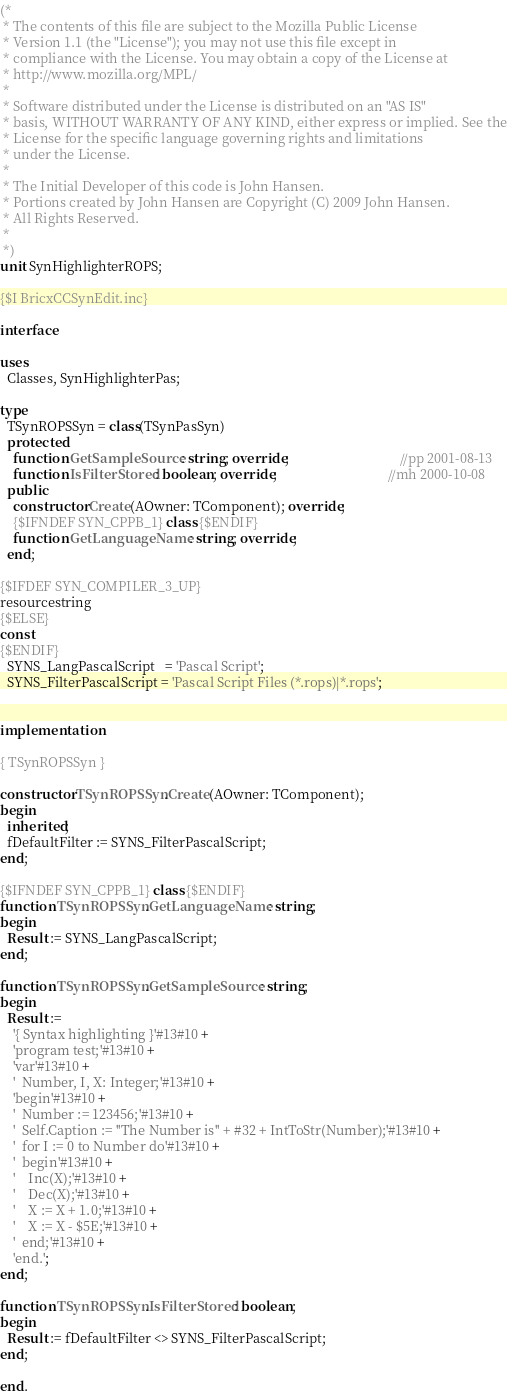<code> <loc_0><loc_0><loc_500><loc_500><_Pascal_>(*
 * The contents of this file are subject to the Mozilla Public License
 * Version 1.1 (the "License"); you may not use this file except in
 * compliance with the License. You may obtain a copy of the License at
 * http://www.mozilla.org/MPL/
 *
 * Software distributed under the License is distributed on an "AS IS"
 * basis, WITHOUT WARRANTY OF ANY KIND, either express or implied. See the
 * License for the specific language governing rights and limitations
 * under the License.
 *
 * The Initial Developer of this code is John Hansen.
 * Portions created by John Hansen are Copyright (C) 2009 John Hansen.
 * All Rights Reserved.
 *
 *)
unit SynHighlighterROPS;

{$I BricxCCSynEdit.inc}

interface

uses
  Classes, SynHighlighterPas;

type
  TSynROPSSyn = class(TSynPasSyn)
  protected
    function GetSampleSource: string; override;                                 //pp 2001-08-13
    function IsFilterStored: boolean; override;                                 //mh 2000-10-08
  public
    constructor Create(AOwner: TComponent); override;
    {$IFNDEF SYN_CPPB_1} class {$ENDIF}
    function GetLanguageName: string; override;
  end;

{$IFDEF SYN_COMPILER_3_UP}
resourcestring
{$ELSE}
const
{$ENDIF}
  SYNS_LangPascalScript   = 'Pascal Script';
  SYNS_FilterPascalScript = 'Pascal Script Files (*.rops)|*.rops';


implementation

{ TSynROPSSyn }

constructor TSynROPSSyn.Create(AOwner: TComponent);
begin
  inherited;
  fDefaultFilter := SYNS_FilterPascalScript;
end;

{$IFNDEF SYN_CPPB_1} class {$ENDIF}
function TSynROPSSyn.GetLanguageName: string;
begin
  Result := SYNS_LangPascalScript;
end;

function TSynROPSSyn.GetSampleSource: string;
begin
  Result :=
    '{ Syntax highlighting }'#13#10 +
    'program test;'#13#10 +
    'var'#13#10 +
    '  Number, I, X: Integer;'#13#10 +
    'begin'#13#10 +
    '  Number := 123456;'#13#10 +
    '  Self.Caption := ''The Number is'' + #32 + IntToStr(Number);'#13#10 +
    '  for I := 0 to Number do'#13#10 +
    '  begin'#13#10 +
    '    Inc(X);'#13#10 +
    '    Dec(X);'#13#10 +
    '    X := X + 1.0;'#13#10 +
    '    X := X - $5E;'#13#10 +
    '  end;'#13#10 +
    'end.';
end;

function TSynROPSSyn.IsFilterStored: boolean;
begin
  Result := fDefaultFilter <> SYNS_FilterPascalScript;
end;

end.
</code> 